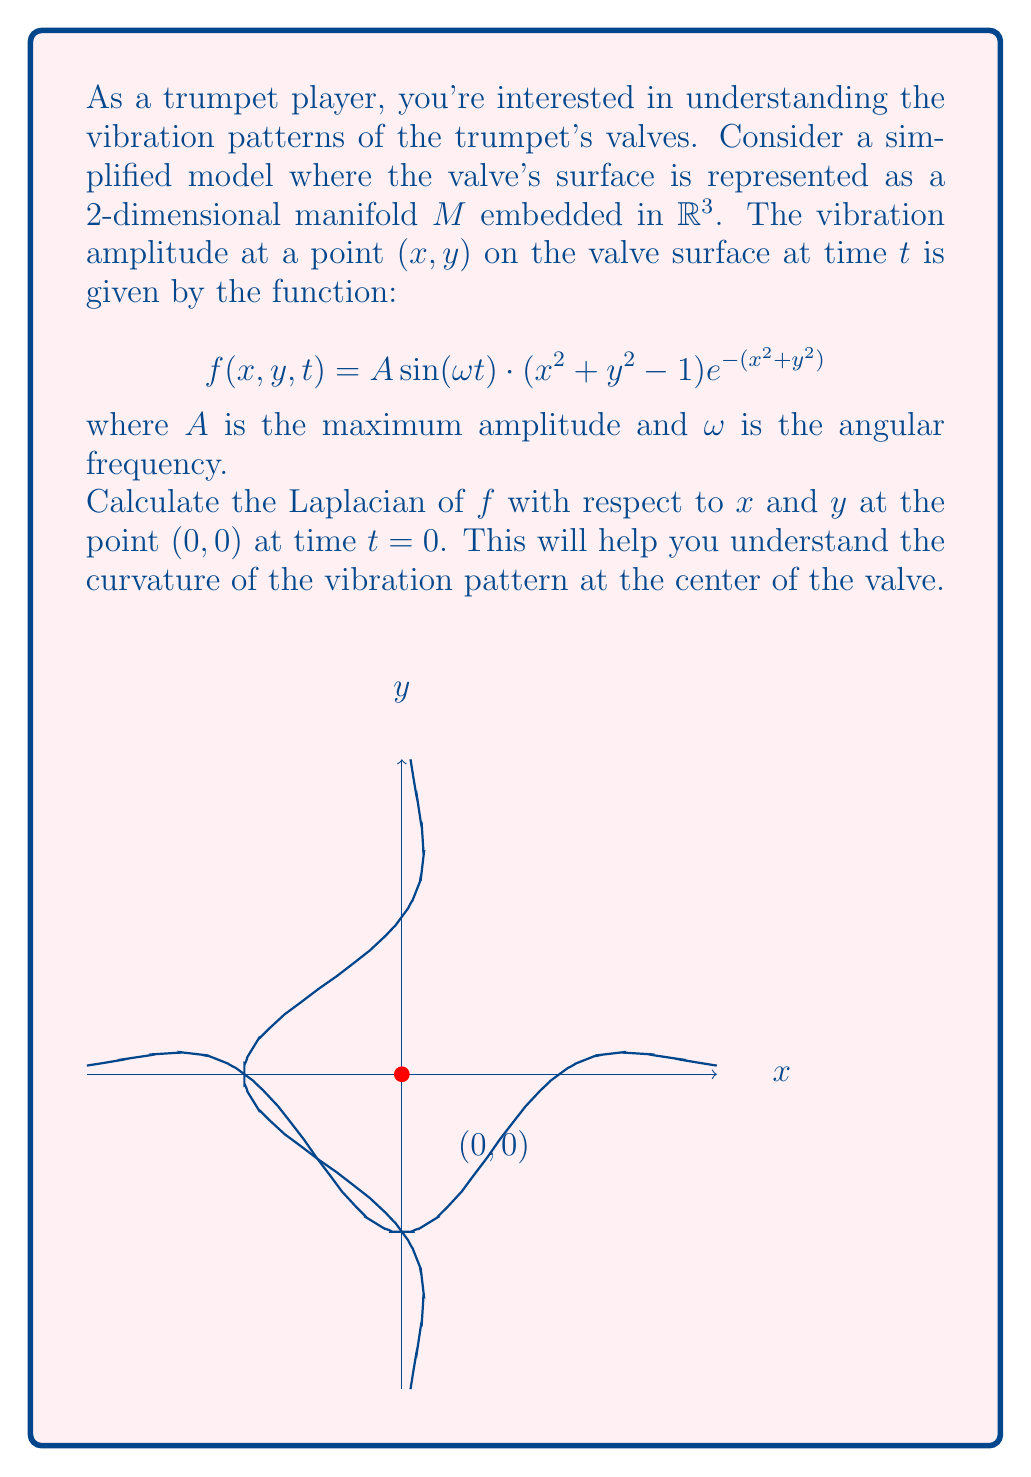Could you help me with this problem? Let's approach this step-by-step:

1) The Laplacian of a function $f(x,y,t)$ with respect to $x$ and $y$ is defined as:

   $$\nabla^2 f = \frac{\partial^2 f}{\partial x^2} + \frac{\partial^2 f}{\partial y^2}$$

2) We need to calculate $\frac{\partial^2 f}{\partial x^2}$ and $\frac{\partial^2 f}{\partial y^2}$ at $(0,0)$ and $t=0$.

3) First, let's separate the time-dependent part:
   
   $$f(x,y,t) = A \sin(\omega t) \cdot g(x,y)$$
   
   where $g(x,y) = (x^2 + y^2 - 1)e^{-(x^2+y^2)}$

4) At $t=0$, $\sin(\omega t) = 0$, so the Laplacian will be zero regardless of $g(x,y)$. However, to fully understand the vibration pattern, we should calculate the Laplacian of $g(x,y)$.

5) Let's calculate $\frac{\partial^2 g}{\partial x^2}$:
   
   $$\frac{\partial g}{\partial x} = (2x)e^{-(x^2+y^2)} + (x^2+y^2-1)(-2x)e^{-(x^2+y^2)}$$
   
   $$\frac{\partial^2 g}{\partial x^2} = 2e^{-(x^2+y^2)} + (-4x^2)e^{-(x^2+y^2)} + (-2x)(-2x)e^{-(x^2+y^2)} + (x^2+y^2-1)(-2)e^{-(x^2+y^2)} + (x^2+y^2-1)(-2x)(-2x)e^{-(x^2+y^2)}$$

6) At $(0,0)$, this simplifies to:
   
   $$\left.\frac{\partial^2 g}{\partial x^2}\right|_{(0,0)} = 2 - 2 = 0$$

7) Due to the symmetry of $g(x,y)$, $\frac{\partial^2 g}{\partial y^2}$ at $(0,0)$ will also be 0.

8) Therefore, the Laplacian of $g$ at $(0,0)$ is:

   $$\nabla^2 g|_{(0,0)} = \frac{\partial^2 g}{\partial x^2}|_{(0,0)} + \frac{\partial^2 g}{\partial y^2}|_{(0,0)} = 0 + 0 = 0$$

9) The full Laplacian of $f$ at $(0,0)$ and $t=0$ is:

   $$\nabla^2 f|_{(0,0,0)} = A \sin(0) \cdot \nabla^2 g|_{(0,0)} = 0 \cdot 0 = 0$$
Answer: 0 